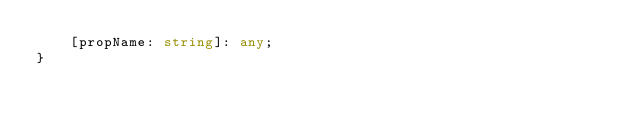<code> <loc_0><loc_0><loc_500><loc_500><_TypeScript_>    [propName: string]: any;
}
</code> 